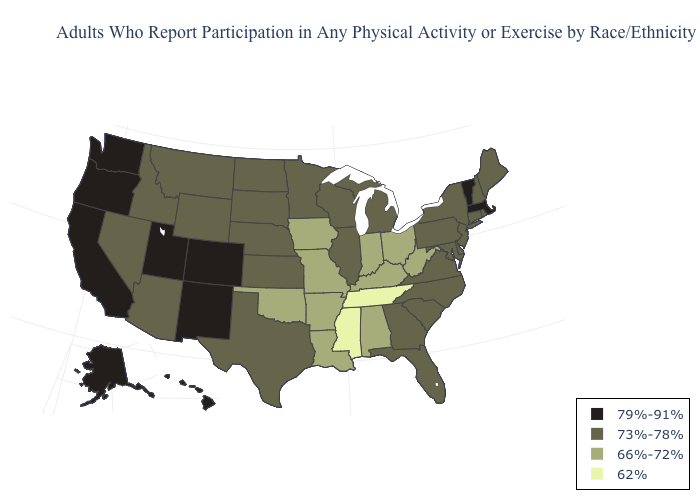Among the states that border Nevada , does Idaho have the highest value?
Be succinct. No. What is the value of Alabama?
Quick response, please. 66%-72%. Does the first symbol in the legend represent the smallest category?
Write a very short answer. No. Does Washington have a lower value than Maine?
Concise answer only. No. Does Colorado have the highest value in the West?
Concise answer only. Yes. Name the states that have a value in the range 66%-72%?
Answer briefly. Alabama, Arkansas, Indiana, Iowa, Kentucky, Louisiana, Missouri, Ohio, Oklahoma, West Virginia. Among the states that border Missouri , which have the lowest value?
Concise answer only. Tennessee. Name the states that have a value in the range 66%-72%?
Give a very brief answer. Alabama, Arkansas, Indiana, Iowa, Kentucky, Louisiana, Missouri, Ohio, Oklahoma, West Virginia. What is the highest value in the South ?
Give a very brief answer. 73%-78%. Among the states that border Arkansas , does Missouri have the lowest value?
Answer briefly. No. Name the states that have a value in the range 62%?
Keep it brief. Mississippi, Tennessee. Name the states that have a value in the range 73%-78%?
Be succinct. Arizona, Connecticut, Delaware, Florida, Georgia, Idaho, Illinois, Kansas, Maine, Maryland, Michigan, Minnesota, Montana, Nebraska, Nevada, New Hampshire, New Jersey, New York, North Carolina, North Dakota, Pennsylvania, Rhode Island, South Carolina, South Dakota, Texas, Virginia, Wisconsin, Wyoming. Among the states that border New York , does New Jersey have the lowest value?
Give a very brief answer. Yes. What is the value of Wisconsin?
Be succinct. 73%-78%. What is the lowest value in the USA?
Be succinct. 62%. 